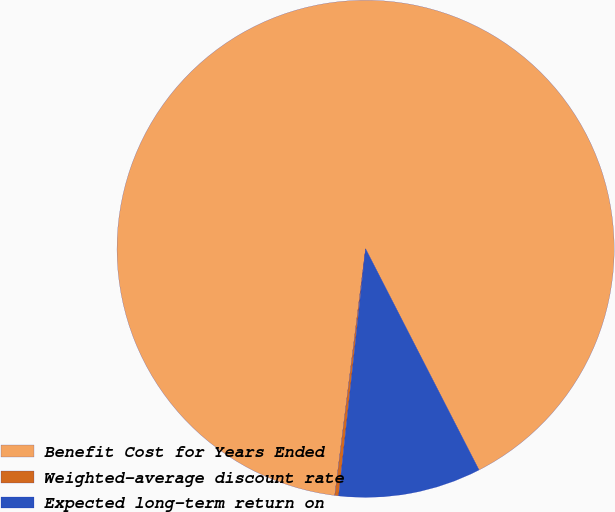Convert chart. <chart><loc_0><loc_0><loc_500><loc_500><pie_chart><fcel>Benefit Cost for Years Ended<fcel>Weighted-average discount rate<fcel>Expected long-term return on<nl><fcel>90.48%<fcel>0.25%<fcel>9.27%<nl></chart> 